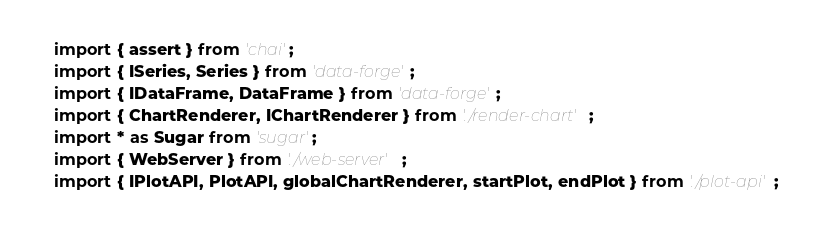Convert code to text. <code><loc_0><loc_0><loc_500><loc_500><_TypeScript_>import { assert } from 'chai';
import { ISeries, Series } from 'data-forge';
import { IDataFrame, DataFrame } from 'data-forge';
import { ChartRenderer, IChartRenderer } from './render-chart';
import * as Sugar from 'sugar';
import { WebServer } from './web-server';
import { IPlotAPI, PlotAPI, globalChartRenderer, startPlot, endPlot } from './plot-api';</code> 